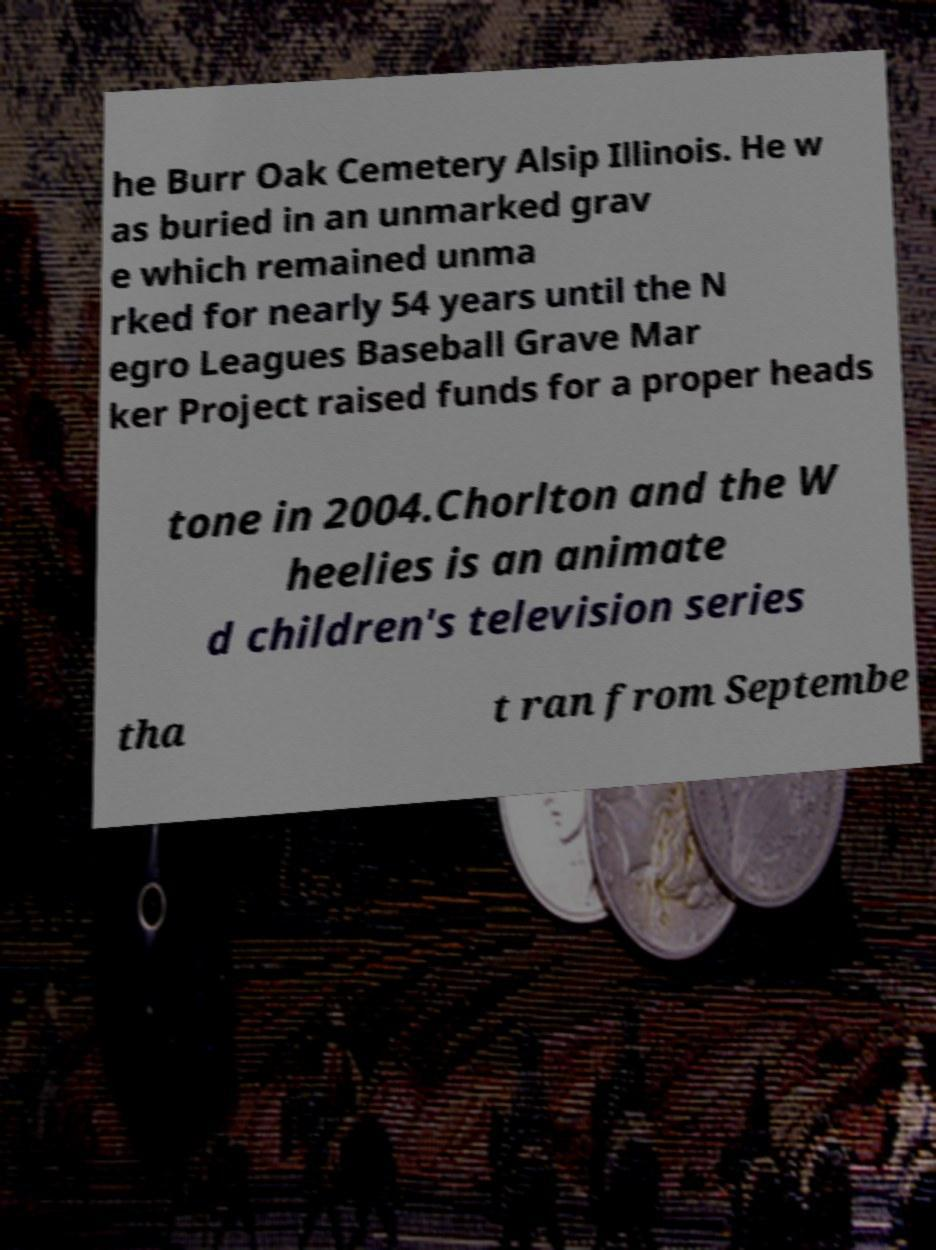What messages or text are displayed in this image? I need them in a readable, typed format. he Burr Oak Cemetery Alsip Illinois. He w as buried in an unmarked grav e which remained unma rked for nearly 54 years until the N egro Leagues Baseball Grave Mar ker Project raised funds for a proper heads tone in 2004.Chorlton and the W heelies is an animate d children's television series tha t ran from Septembe 